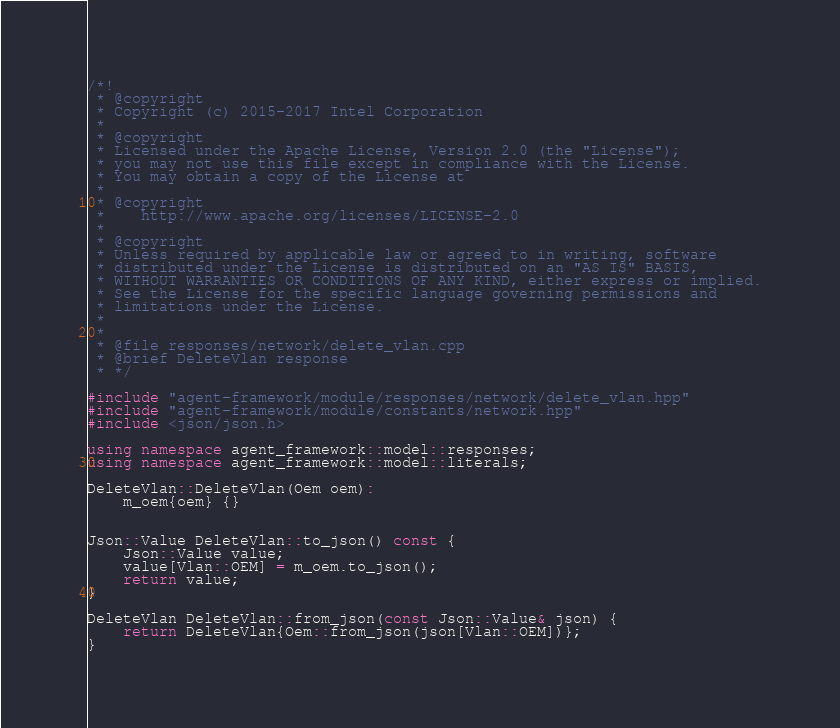<code> <loc_0><loc_0><loc_500><loc_500><_C++_>/*!
 * @copyright
 * Copyright (c) 2015-2017 Intel Corporation
 *
 * @copyright
 * Licensed under the Apache License, Version 2.0 (the "License");
 * you may not use this file except in compliance with the License.
 * You may obtain a copy of the License at
 *
 * @copyright
 *    http://www.apache.org/licenses/LICENSE-2.0
 *
 * @copyright
 * Unless required by applicable law or agreed to in writing, software
 * distributed under the License is distributed on an "AS IS" BASIS,
 * WITHOUT WARRANTIES OR CONDITIONS OF ANY KIND, either express or implied.
 * See the License for the specific language governing permissions and
 * limitations under the License.
 *
 *
 * @file responses/network/delete_vlan.cpp
 * @brief DeleteVlan response
 * */

#include "agent-framework/module/responses/network/delete_vlan.hpp"
#include "agent-framework/module/constants/network.hpp"
#include <json/json.h>

using namespace agent_framework::model::responses;
using namespace agent_framework::model::literals;

DeleteVlan::DeleteVlan(Oem oem):
    m_oem{oem} {}


Json::Value DeleteVlan::to_json() const {
    Json::Value value;
    value[Vlan::OEM] = m_oem.to_json();
    return value;
}

DeleteVlan DeleteVlan::from_json(const Json::Value& json) {
    return DeleteVlan{Oem::from_json(json[Vlan::OEM])};
}
</code> 